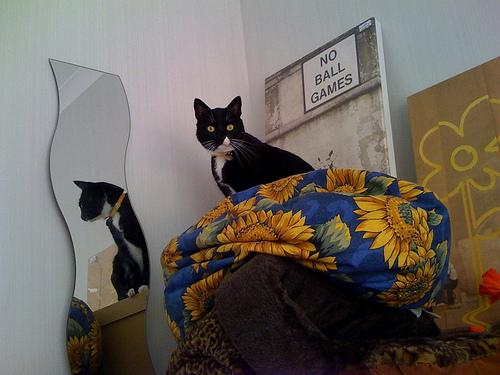Write a brief, poetic description of the main subject of the image and its immediate surroundings. A black and white feline muse, with eyes of gold upon a blanket's floral hues, mirrored, still and self-reflected. Write a concise but detailed summary of the primary object in the image and its immediate surroundings. The image features a black and white cat with yellow eyes situated on a blue and yellow floral blanket, accompanied by a mirror reflecting the scene. State the main subject of the image, and give a brief explanation of the area surrounding it. The image shows a black and white cat sitting on a flowery blanket, with a mirror reflecting the cat and blanket nearby. Use a playful tone to briefly describe the focal point of the image and its most distinct characteristic. A curious black and white kitty with striking yellow eyes sits on a pretty flowery blanket, ready to play! Provide a concise summary of the main object in the image and the noteworthy item it's interacting with. A black and white cat sits on a blanket with a blue and yellow sunflower design, its reflection visible in a mirror. Provide a brief description of the primary object in the picture and its most noticeable feature. Black and white cat with yellow eyes sitting on a blue and yellow floral blanket. Using a creative approach, write a brief description of the main subject in the image and its environment. A canvas of fur and flowers unfolds, as a black and white feline with eyes like burning embers lounges upon a vibrant blanket, only to meet its reflection in the mirror. Describe the central subject in the image and the surrounding objects, using formal language. In the photograph, a black and white feline specimen with yellow eyes occupies a floral-patterned blanket, adjacent to a reflective mirror displaying its likeness. Use casual language to briefly describe the main subject of the image and its environment. This cute black and white cat with yellow eyes is just chillin' on a flowery blanket, and you can even see it in the mirror next to it! Write a minimalist description of the main subject in the image and its distinguishing feature. Cat, black and white, yellow eyes. 